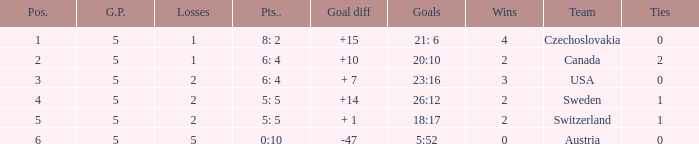What was the largest tie when the G.P was more than 5? None. 